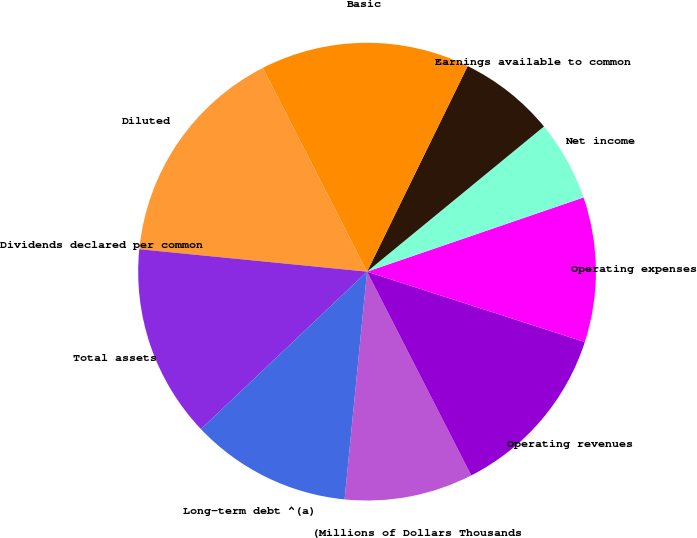Convert chart to OTSL. <chart><loc_0><loc_0><loc_500><loc_500><pie_chart><fcel>(Millions of Dollars Thousands<fcel>Operating revenues<fcel>Operating expenses<fcel>Net income<fcel>Earnings available to common<fcel>Basic<fcel>Diluted<fcel>Dividends declared per common<fcel>Total assets<fcel>Long-term debt ^(a)<nl><fcel>9.09%<fcel>12.5%<fcel>10.23%<fcel>5.68%<fcel>6.82%<fcel>14.77%<fcel>15.91%<fcel>0.0%<fcel>13.64%<fcel>11.36%<nl></chart> 